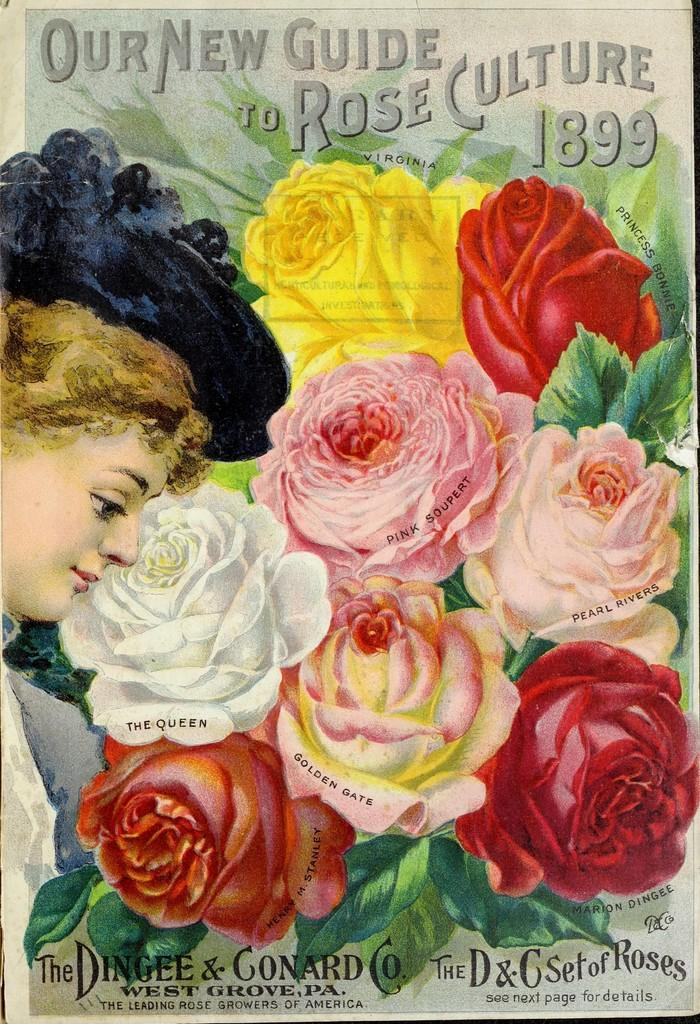What is the main subject of the poster in the image? The poster contains pictures of flowers, leaves, and a woman. What other elements can be found on the poster? There is text written on the poster. How does the cake turn into a rock in the image? There is no cake or rock present in the image; the poster contains pictures of flowers, leaves, and a woman. 